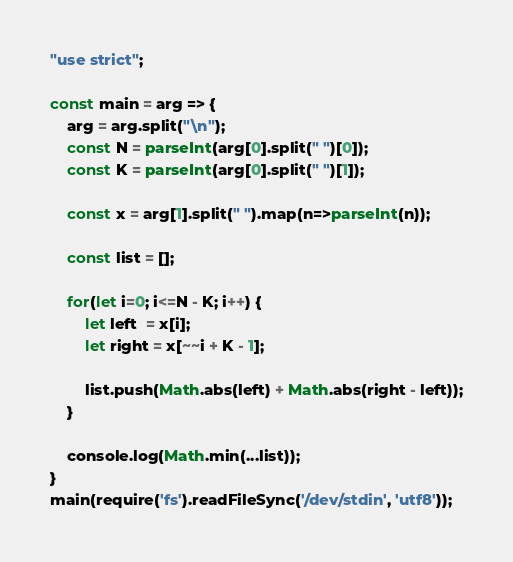Convert code to text. <code><loc_0><loc_0><loc_500><loc_500><_JavaScript_>"use strict";
    
const main = arg => {
    arg = arg.split("\n");
    const N = parseInt(arg[0].split(" ")[0]);
    const K = parseInt(arg[0].split(" ")[1]);
    
    const x = arg[1].split(" ").map(n=>parseInt(n));
    
    const list = [];
    
    for(let i=0; i<=N - K; i++) {
        let left  = x[i];
        let right = x[~~i + K - 1];
        
        list.push(Math.abs(left) + Math.abs(right - left));
    }
    
    console.log(Math.min(...list));
}
main(require('fs').readFileSync('/dev/stdin', 'utf8'));</code> 